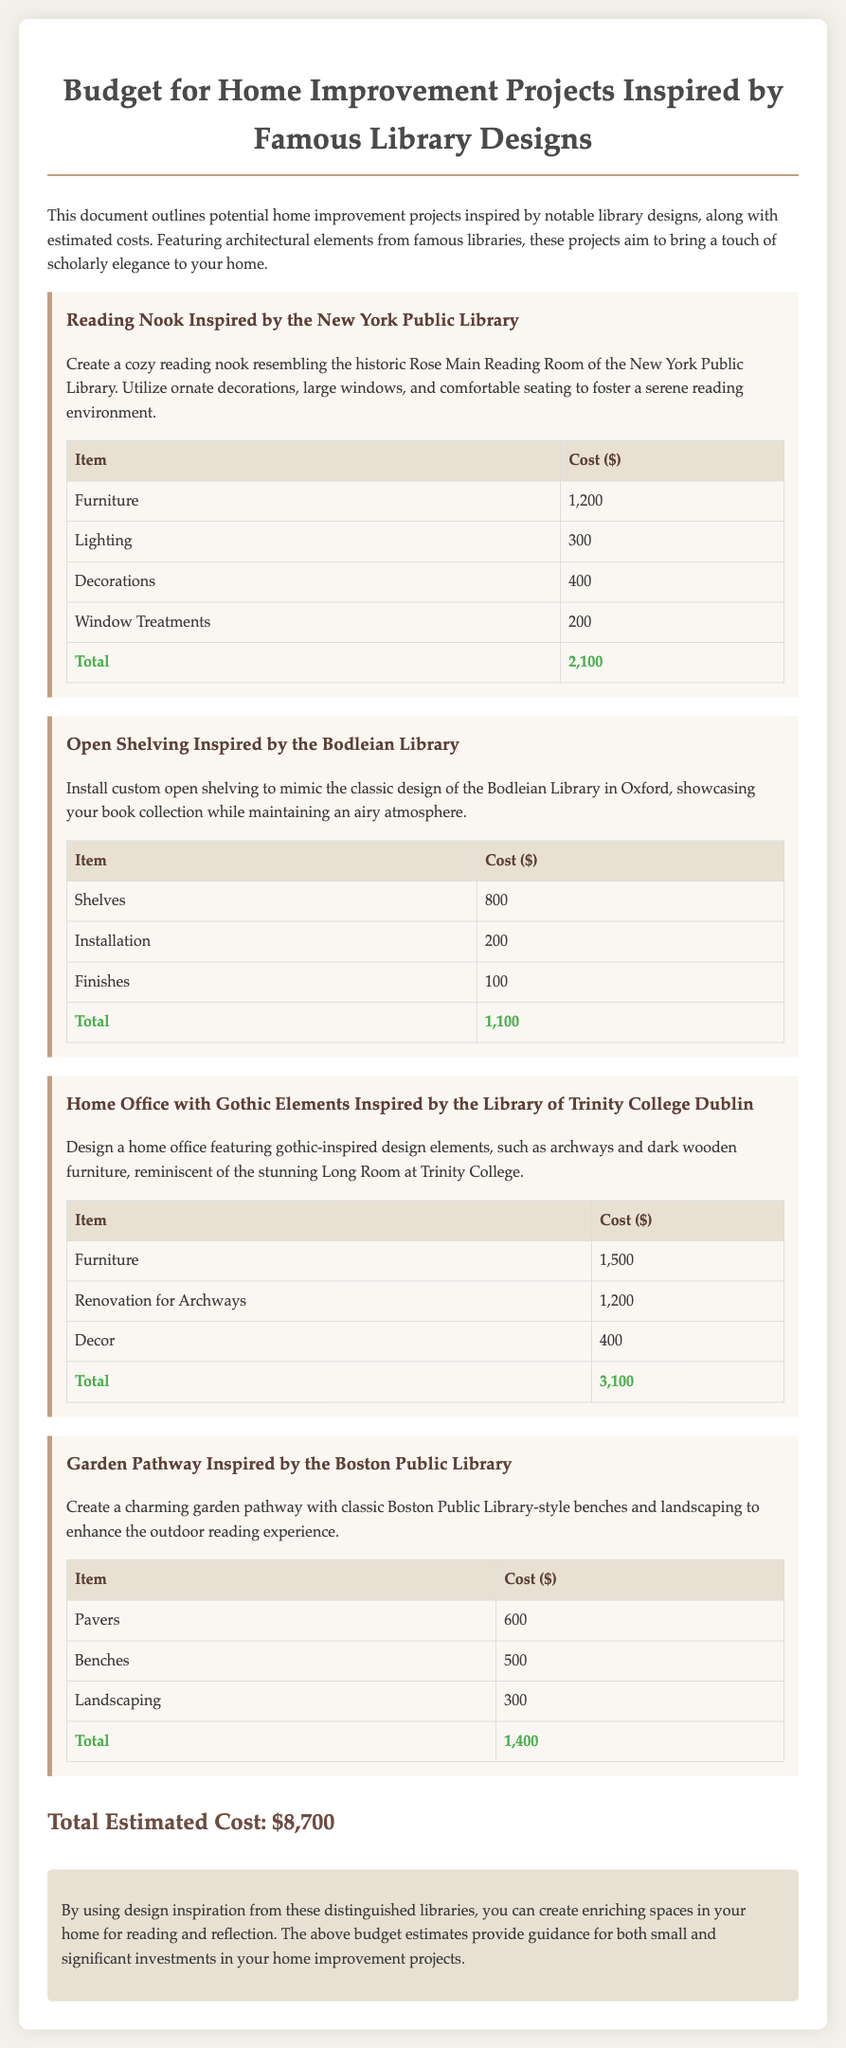What is the total estimated cost for home improvement projects? The total estimated cost is provided at the end of the document, summing all individual project costs.
Answer: $8,700 How much does the reading nook inspired by the New York Public Library cost? The cost for the reading nook is outlined in the cost table for that specific project.
Answer: $2,100 What are the gothic elements mentioned for the home office design? The document highlights specific architectural elements that evoke a gothic style in the home office design inspired by Trinity College.
Answer: Archways and dark wooden furniture How much do the open shelving inspired by the Bodleian Library cost? This cost can be found in the budget section where the items for the project are listed along with their respective costs.
Answer: $1,100 What is one item mentioned under the garden pathway project? The garden pathway project includes various items needed for its completion, one of which is specifically listed.
Answer: Pavers What library design inspired the garden pathway project? The inspiration for the garden pathway is drawn from a well-known library, as specified in the project description.
Answer: Boston Public Library What is the cost for furniture in the home office project? The furniture cost is specified in the cost table for the home office with gothic elements.
Answer: $1,500 What type of seating is suggested for the reading nook? The reading nook description includes a specific type of furniture that enhances the reading space.
Answer: Comfortable seating 